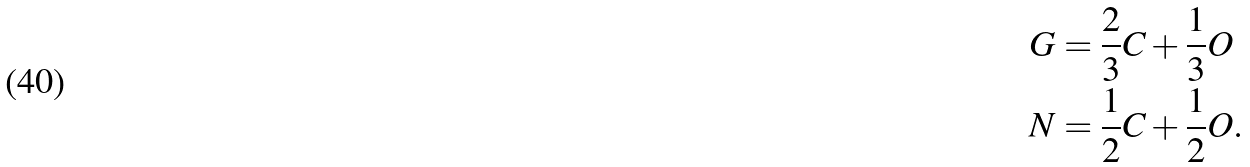<formula> <loc_0><loc_0><loc_500><loc_500>G & = \frac { 2 } { 3 } C + \frac { 1 } { 3 } O \\ N & = \frac { 1 } { 2 } C + \frac { 1 } { 2 } O .</formula> 